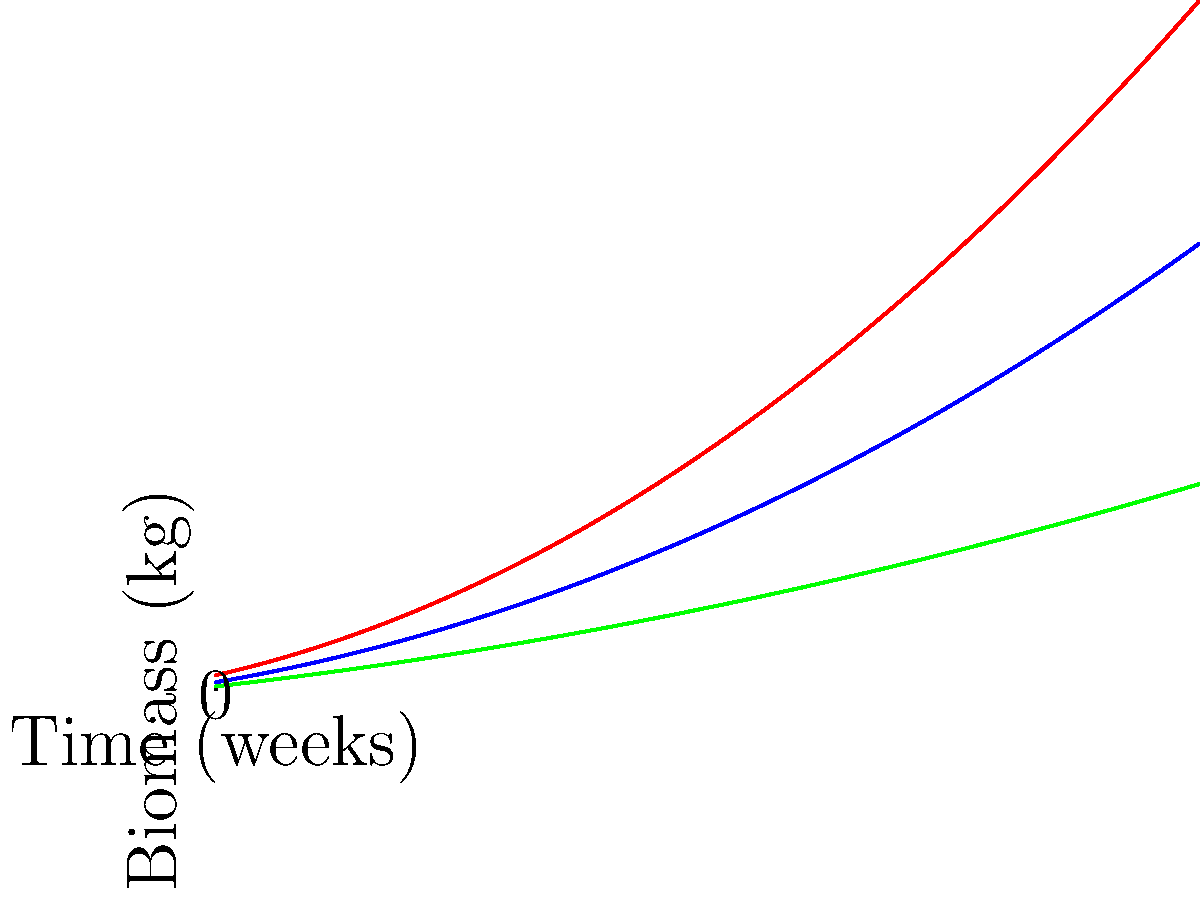The graph shows the biomass accumulation of cassava plants grown in three different soil types over an 8-week period in Uganda. Which soil type resulted in the highest biomass accumulation rate, and what factors might contribute to this difference in growth patterns? To answer this question, we need to analyze the graph and consider the botanical characteristics of cassava and soil properties:

1. Observe the curves: The red curve (clay soil) shows the steepest increase, followed by the blue curve (loamy soil), and then the green curve (sandy soil).

2. Compare growth rates: The slope of each curve represents the growth rate. The red curve has the steepest slope, indicating the highest growth rate.

3. Final biomass: At week 8, the clay soil results in the highest biomass, followed by loamy soil, then sandy soil.

4. Soil characteristics:
   - Clay soil: High water retention, rich in nutrients, but can be poorly aerated.
   - Loamy soil: Good balance of water retention, nutrient content, and aeration.
   - Sandy soil: Well-aerated but poor water and nutrient retention.

5. Cassava's preferences: Cassava generally prefers well-drained, fertile soils but can tolerate poor soil conditions.

6. Factors contributing to differences:
   a) Nutrient availability: Clay soils often have higher nutrient content, supporting faster growth.
   b) Water retention: Clay soils retain water better, which is crucial for biomass accumulation.
   c) Root development: The soil structure affects root growth, impacting nutrient uptake and overall plant growth.

7. Conclusion: Clay soil resulted in the highest biomass accumulation rate, likely due to its superior water and nutrient retention properties, which align well with cassava's growth requirements in Uganda's climate.
Answer: Clay soil; higher nutrient and water retention 